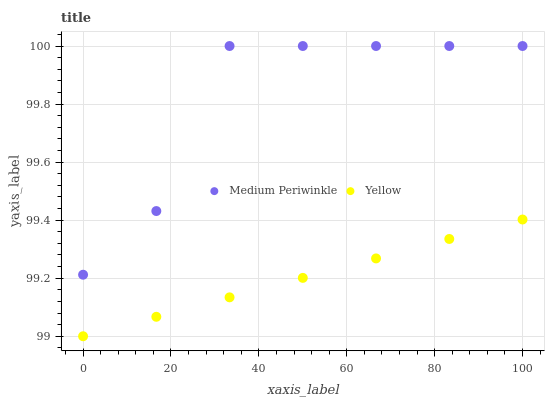Does Yellow have the minimum area under the curve?
Answer yes or no. Yes. Does Medium Periwinkle have the maximum area under the curve?
Answer yes or no. Yes. Does Yellow have the maximum area under the curve?
Answer yes or no. No. Is Yellow the smoothest?
Answer yes or no. Yes. Is Medium Periwinkle the roughest?
Answer yes or no. Yes. Is Yellow the roughest?
Answer yes or no. No. Does Yellow have the lowest value?
Answer yes or no. Yes. Does Medium Periwinkle have the highest value?
Answer yes or no. Yes. Does Yellow have the highest value?
Answer yes or no. No. Is Yellow less than Medium Periwinkle?
Answer yes or no. Yes. Is Medium Periwinkle greater than Yellow?
Answer yes or no. Yes. Does Yellow intersect Medium Periwinkle?
Answer yes or no. No. 